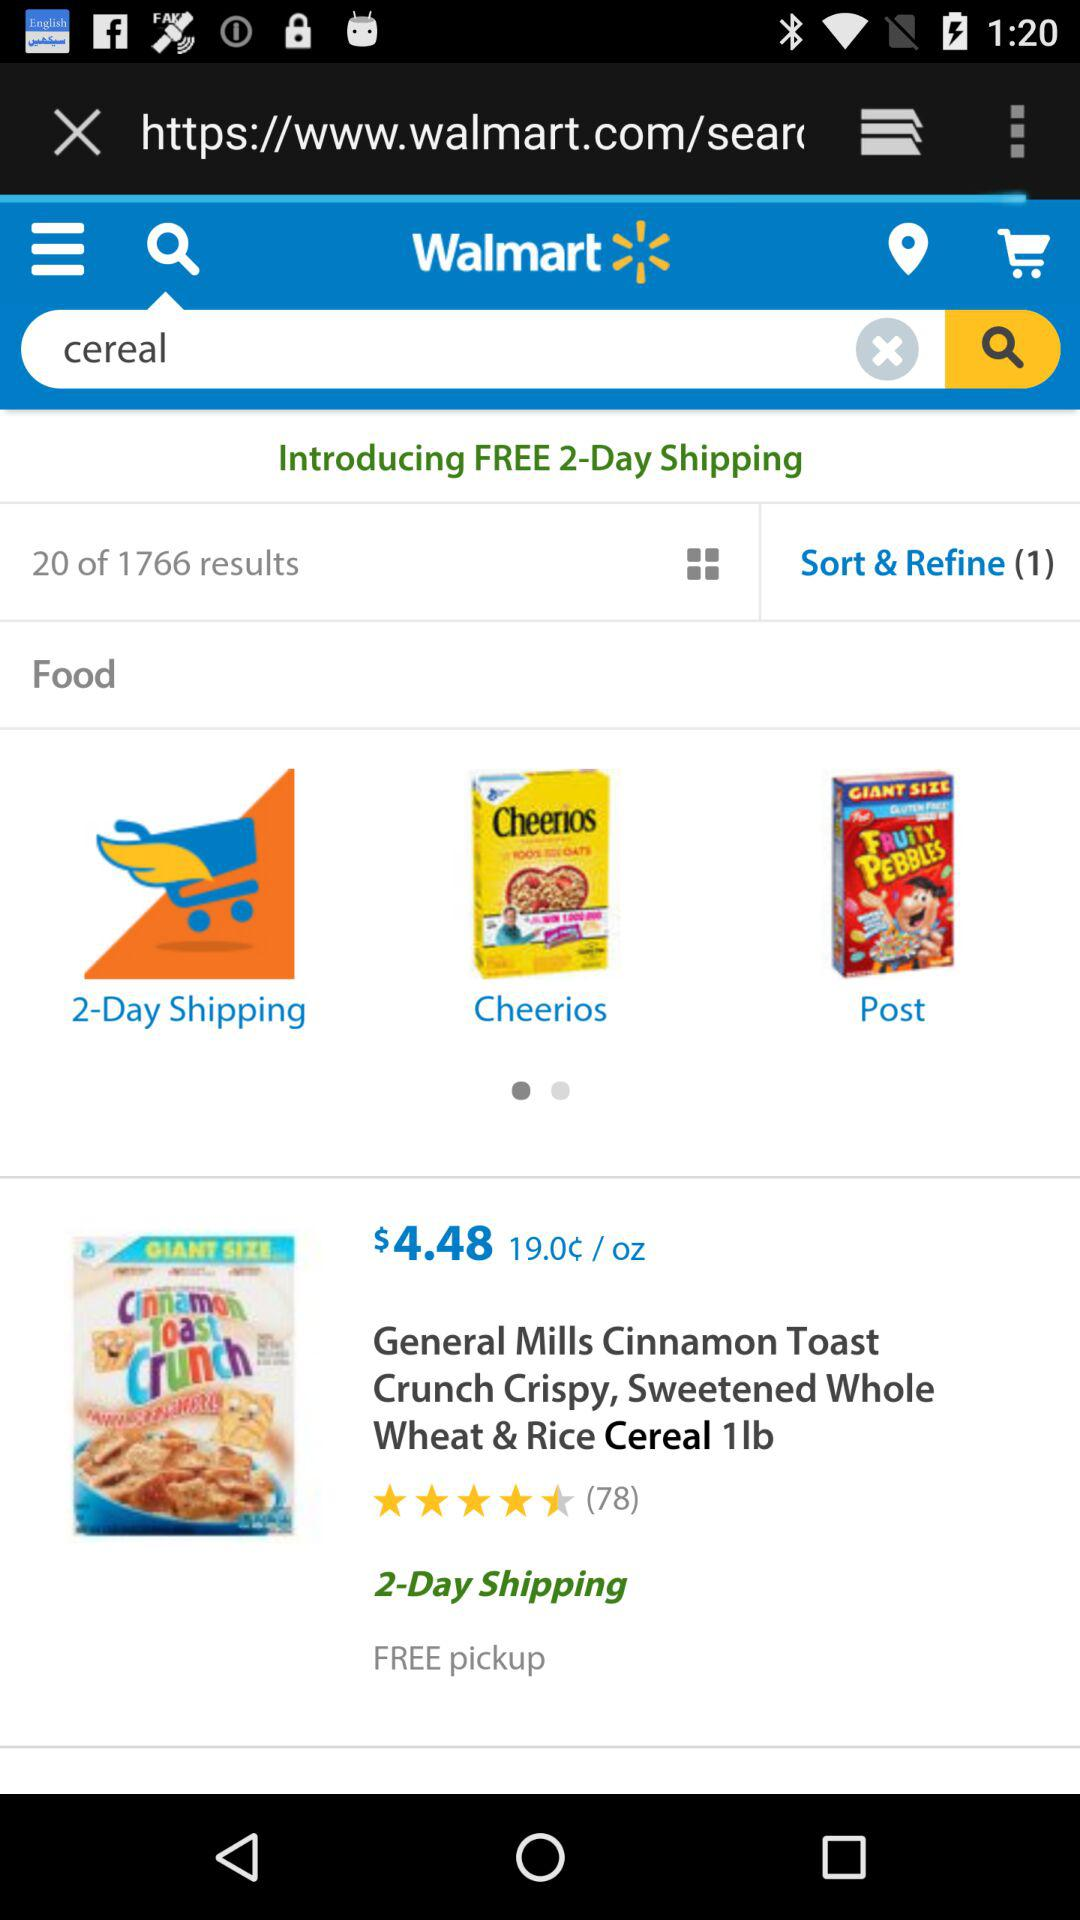What's the number of "Free Day Shipping"? The number of "Free Day Shipping" is 2. 